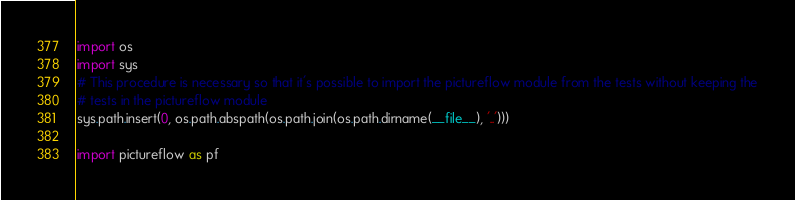<code> <loc_0><loc_0><loc_500><loc_500><_Python_>import os
import sys
# This procedure is necessary so that it's possible to import the pictureflow module from the tests without keeping the
# tests in the pictureflow module
sys.path.insert(0, os.path.abspath(os.path.join(os.path.dirname(__file__), '..')))

import pictureflow as pf
</code> 